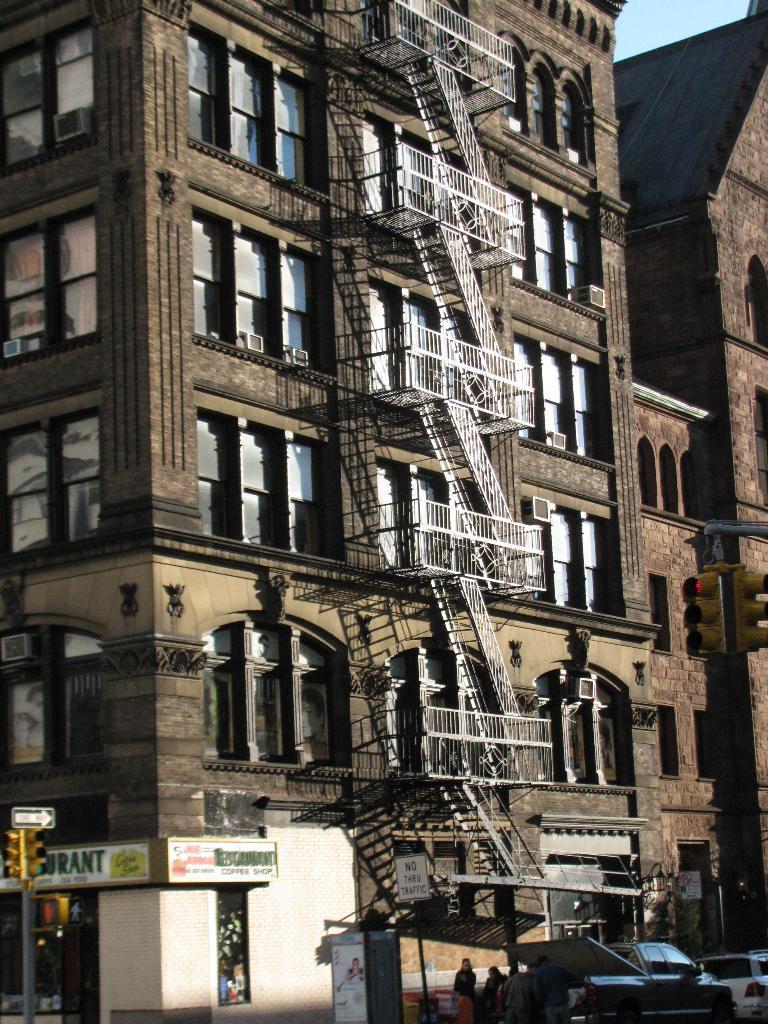In one or two sentences, can you explain what this image depicts? This is the picture of a building. In this image there are buildings. At the bottom there are group of people standing and there are vehicles on the road. There are traffic signal poles on the footpath and there are hoardings to the building. At the top there is sky. At the bottom there is a road. 